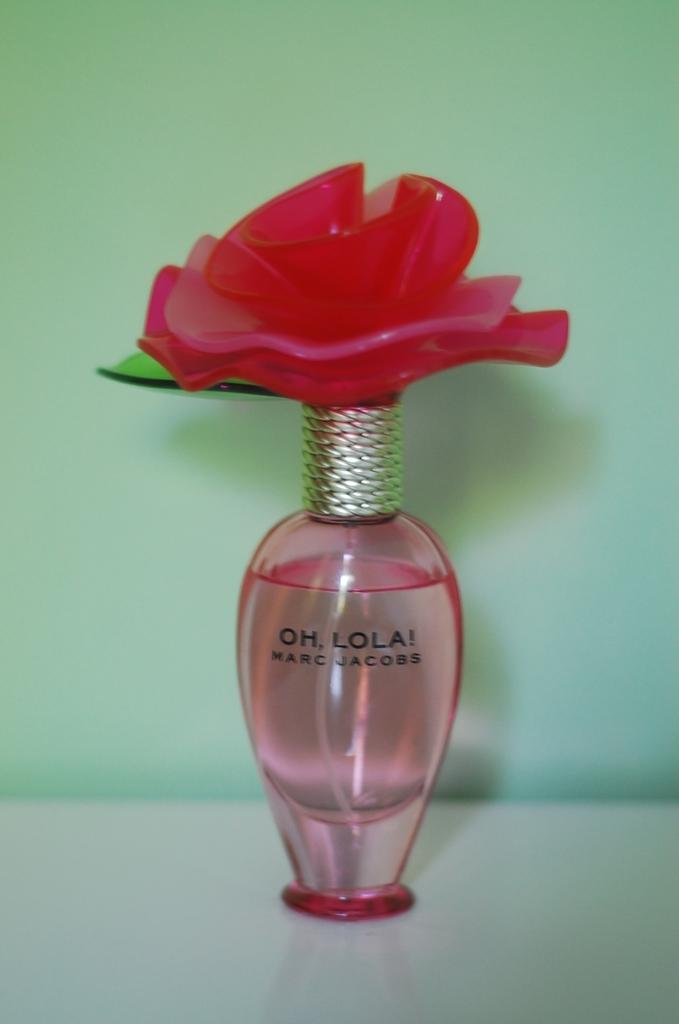<image>
Offer a succinct explanation of the picture presented. pink bottle of oh, lola! by marc jacobs against a green wall 